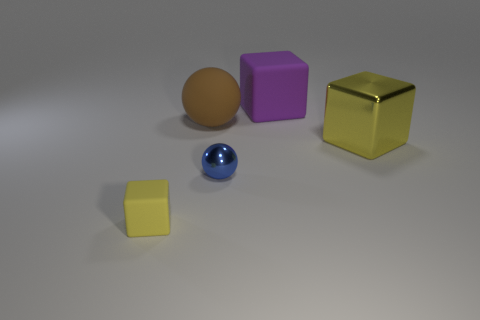Subtract all large matte cubes. How many cubes are left? 2 Subtract 1 cubes. How many cubes are left? 2 Add 1 metal blocks. How many objects exist? 6 Subtract all yellow spheres. Subtract all big rubber spheres. How many objects are left? 4 Add 5 blue balls. How many blue balls are left? 6 Add 3 tiny purple shiny balls. How many tiny purple shiny balls exist? 3 Subtract 0 yellow balls. How many objects are left? 5 Subtract all blocks. How many objects are left? 2 